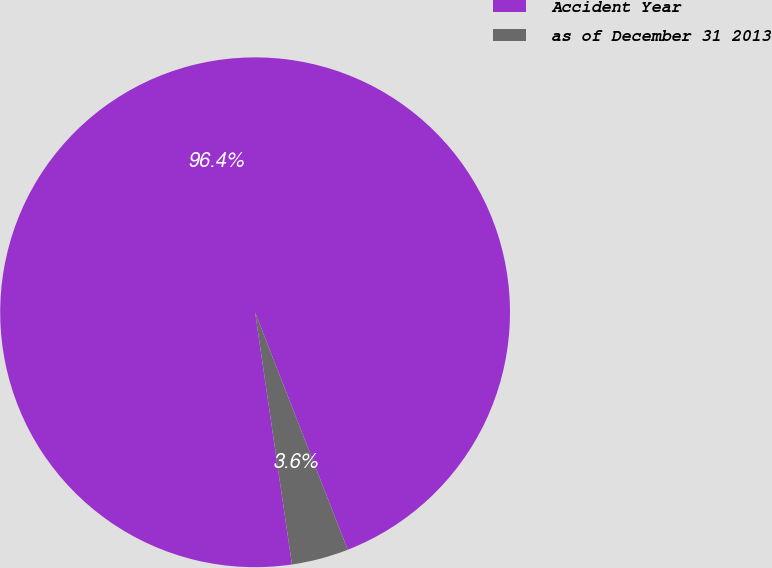<chart> <loc_0><loc_0><loc_500><loc_500><pie_chart><fcel>Accident Year<fcel>as of December 31 2013<nl><fcel>96.39%<fcel>3.61%<nl></chart> 